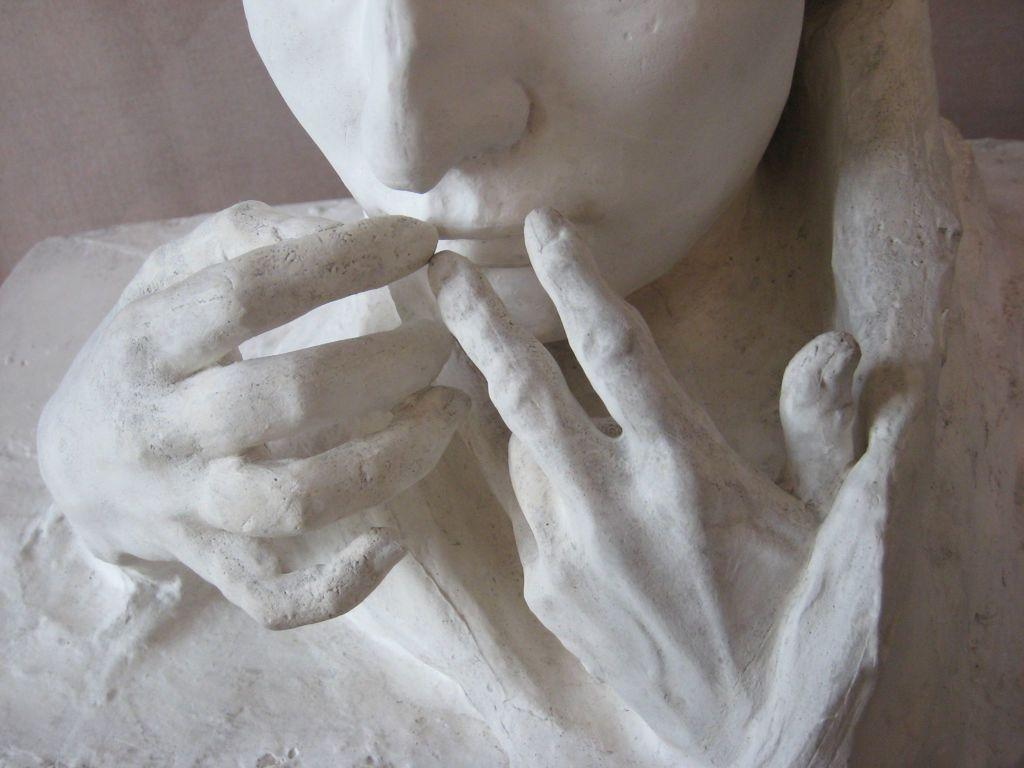What is the main subject of the image? The main subject of the image is a sculpture. Can you describe the sculpture in more detail? The sculpture is truncated. Where is the basin located in the image? There is no basin present in the image. What type of fork can be seen in the image? There is no fork present in the image. 